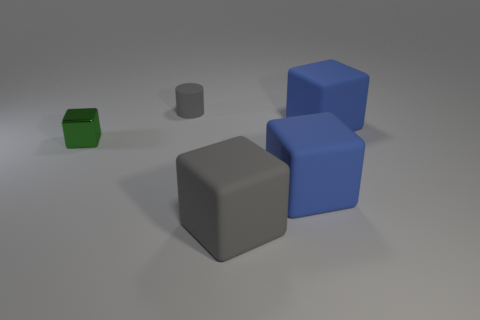What number of objects are gray rubber cylinders that are on the right side of the small green thing or cylinders? There are two gray rubber cylinders located to the right of the small green cube in the image. 